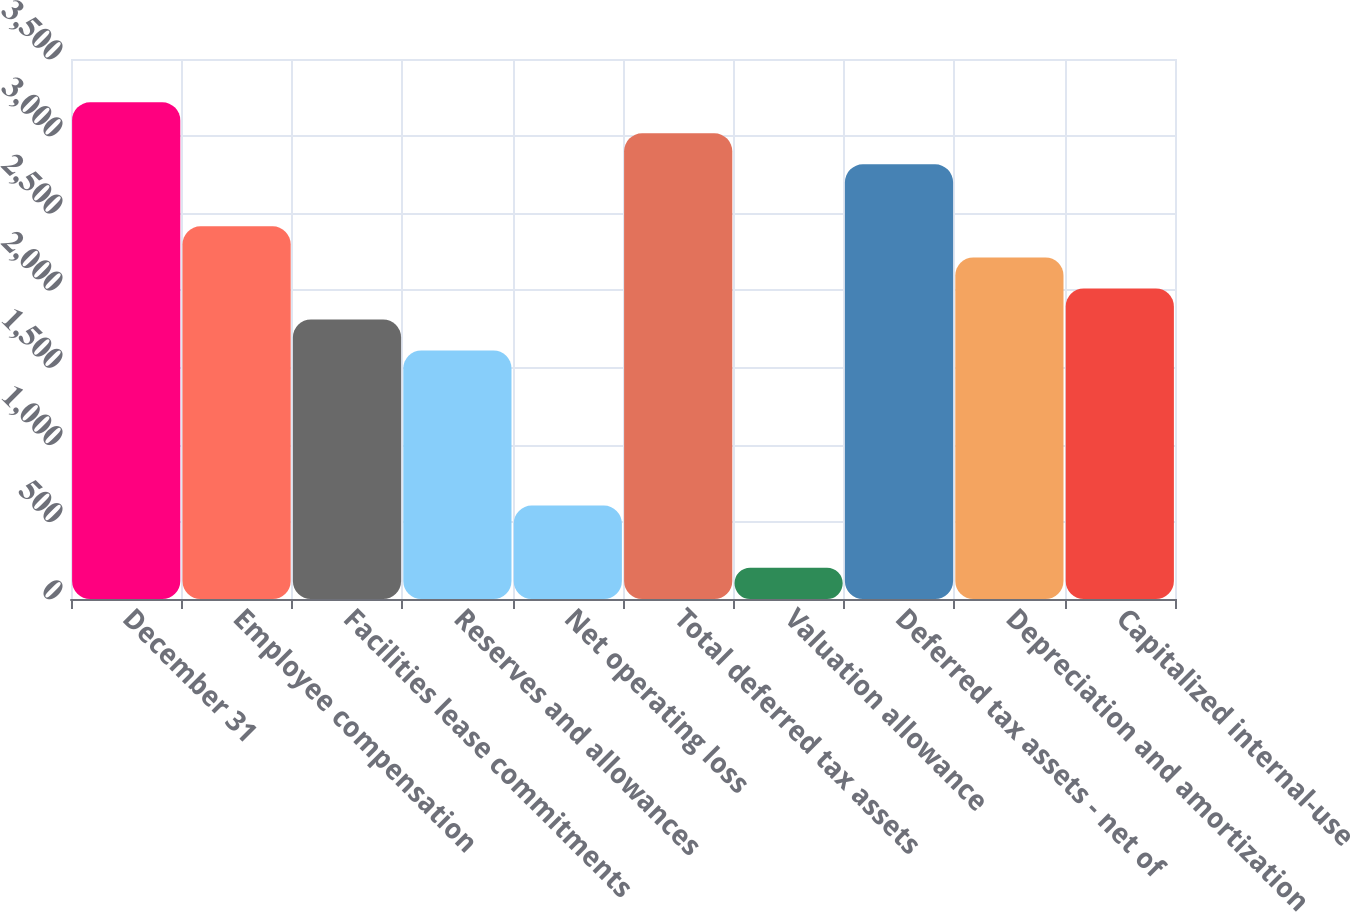Convert chart. <chart><loc_0><loc_0><loc_500><loc_500><bar_chart><fcel>December 31<fcel>Employee compensation<fcel>Facilities lease commitments<fcel>Reserves and allowances<fcel>Net operating loss<fcel>Total deferred tax assets<fcel>Valuation allowance<fcel>Deferred tax assets - net of<fcel>Depreciation and amortization<fcel>Capitalized internal-use<nl><fcel>3219.6<fcel>2415.2<fcel>1811.9<fcel>1610.8<fcel>605.3<fcel>3018.5<fcel>203.1<fcel>2817.4<fcel>2214.1<fcel>2013<nl></chart> 